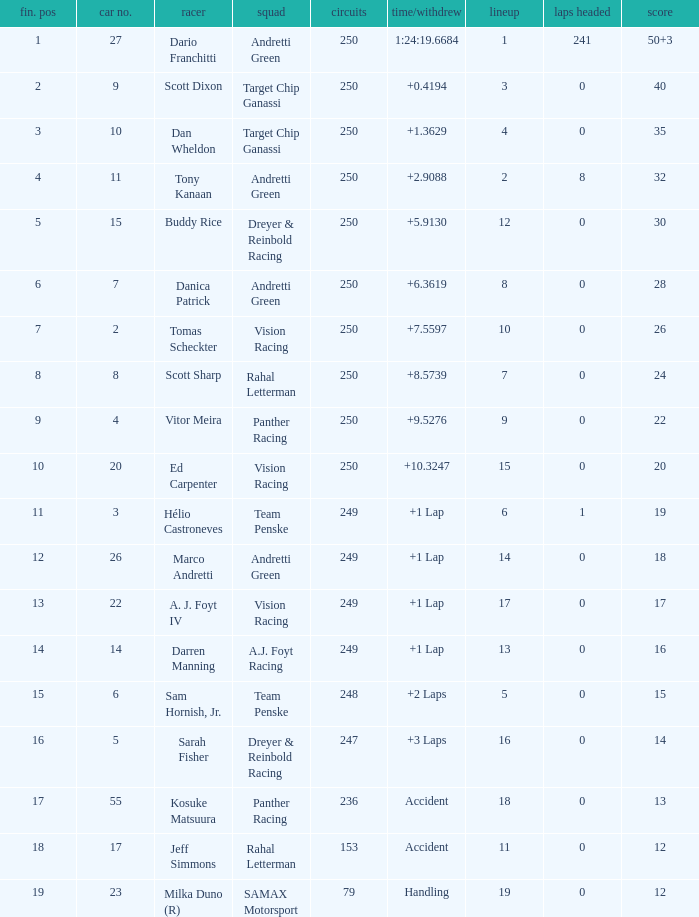Name the total number of fin pos for 12 points of accident 1.0. I'm looking to parse the entire table for insights. Could you assist me with that? {'header': ['fin. pos', 'car no.', 'racer', 'squad', 'circuits', 'time/withdrew', 'lineup', 'laps headed', 'score'], 'rows': [['1', '27', 'Dario Franchitti', 'Andretti Green', '250', '1:24:19.6684', '1', '241', '50+3'], ['2', '9', 'Scott Dixon', 'Target Chip Ganassi', '250', '+0.4194', '3', '0', '40'], ['3', '10', 'Dan Wheldon', 'Target Chip Ganassi', '250', '+1.3629', '4', '0', '35'], ['4', '11', 'Tony Kanaan', 'Andretti Green', '250', '+2.9088', '2', '8', '32'], ['5', '15', 'Buddy Rice', 'Dreyer & Reinbold Racing', '250', '+5.9130', '12', '0', '30'], ['6', '7', 'Danica Patrick', 'Andretti Green', '250', '+6.3619', '8', '0', '28'], ['7', '2', 'Tomas Scheckter', 'Vision Racing', '250', '+7.5597', '10', '0', '26'], ['8', '8', 'Scott Sharp', 'Rahal Letterman', '250', '+8.5739', '7', '0', '24'], ['9', '4', 'Vitor Meira', 'Panther Racing', '250', '+9.5276', '9', '0', '22'], ['10', '20', 'Ed Carpenter', 'Vision Racing', '250', '+10.3247', '15', '0', '20'], ['11', '3', 'Hélio Castroneves', 'Team Penske', '249', '+1 Lap', '6', '1', '19'], ['12', '26', 'Marco Andretti', 'Andretti Green', '249', '+1 Lap', '14', '0', '18'], ['13', '22', 'A. J. Foyt IV', 'Vision Racing', '249', '+1 Lap', '17', '0', '17'], ['14', '14', 'Darren Manning', 'A.J. Foyt Racing', '249', '+1 Lap', '13', '0', '16'], ['15', '6', 'Sam Hornish, Jr.', 'Team Penske', '248', '+2 Laps', '5', '0', '15'], ['16', '5', 'Sarah Fisher', 'Dreyer & Reinbold Racing', '247', '+3 Laps', '16', '0', '14'], ['17', '55', 'Kosuke Matsuura', 'Panther Racing', '236', 'Accident', '18', '0', '13'], ['18', '17', 'Jeff Simmons', 'Rahal Letterman', '153', 'Accident', '11', '0', '12'], ['19', '23', 'Milka Duno (R)', 'SAMAX Motorsport', '79', 'Handling', '19', '0', '12']]} 